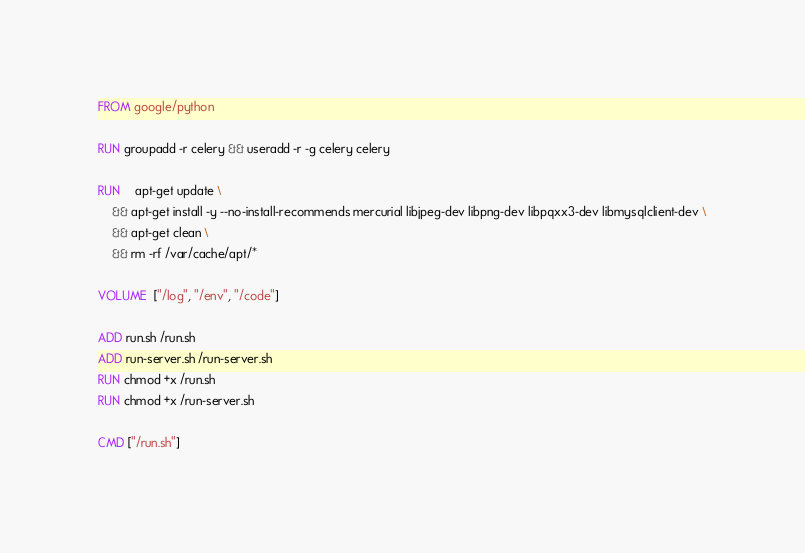<code> <loc_0><loc_0><loc_500><loc_500><_Dockerfile_>FROM google/python

RUN groupadd -r celery && useradd -r -g celery celery

RUN    apt-get update \
    && apt-get install -y --no-install-recommends mercurial libjpeg-dev libpng-dev libpqxx3-dev libmysqlclient-dev \
    && apt-get clean \
    && rm -rf /var/cache/apt/*

VOLUME  ["/log", "/env", "/code"]

ADD run.sh /run.sh
ADD run-server.sh /run-server.sh
RUN chmod +x /run.sh
RUN chmod +x /run-server.sh

CMD ["/run.sh"]
</code> 